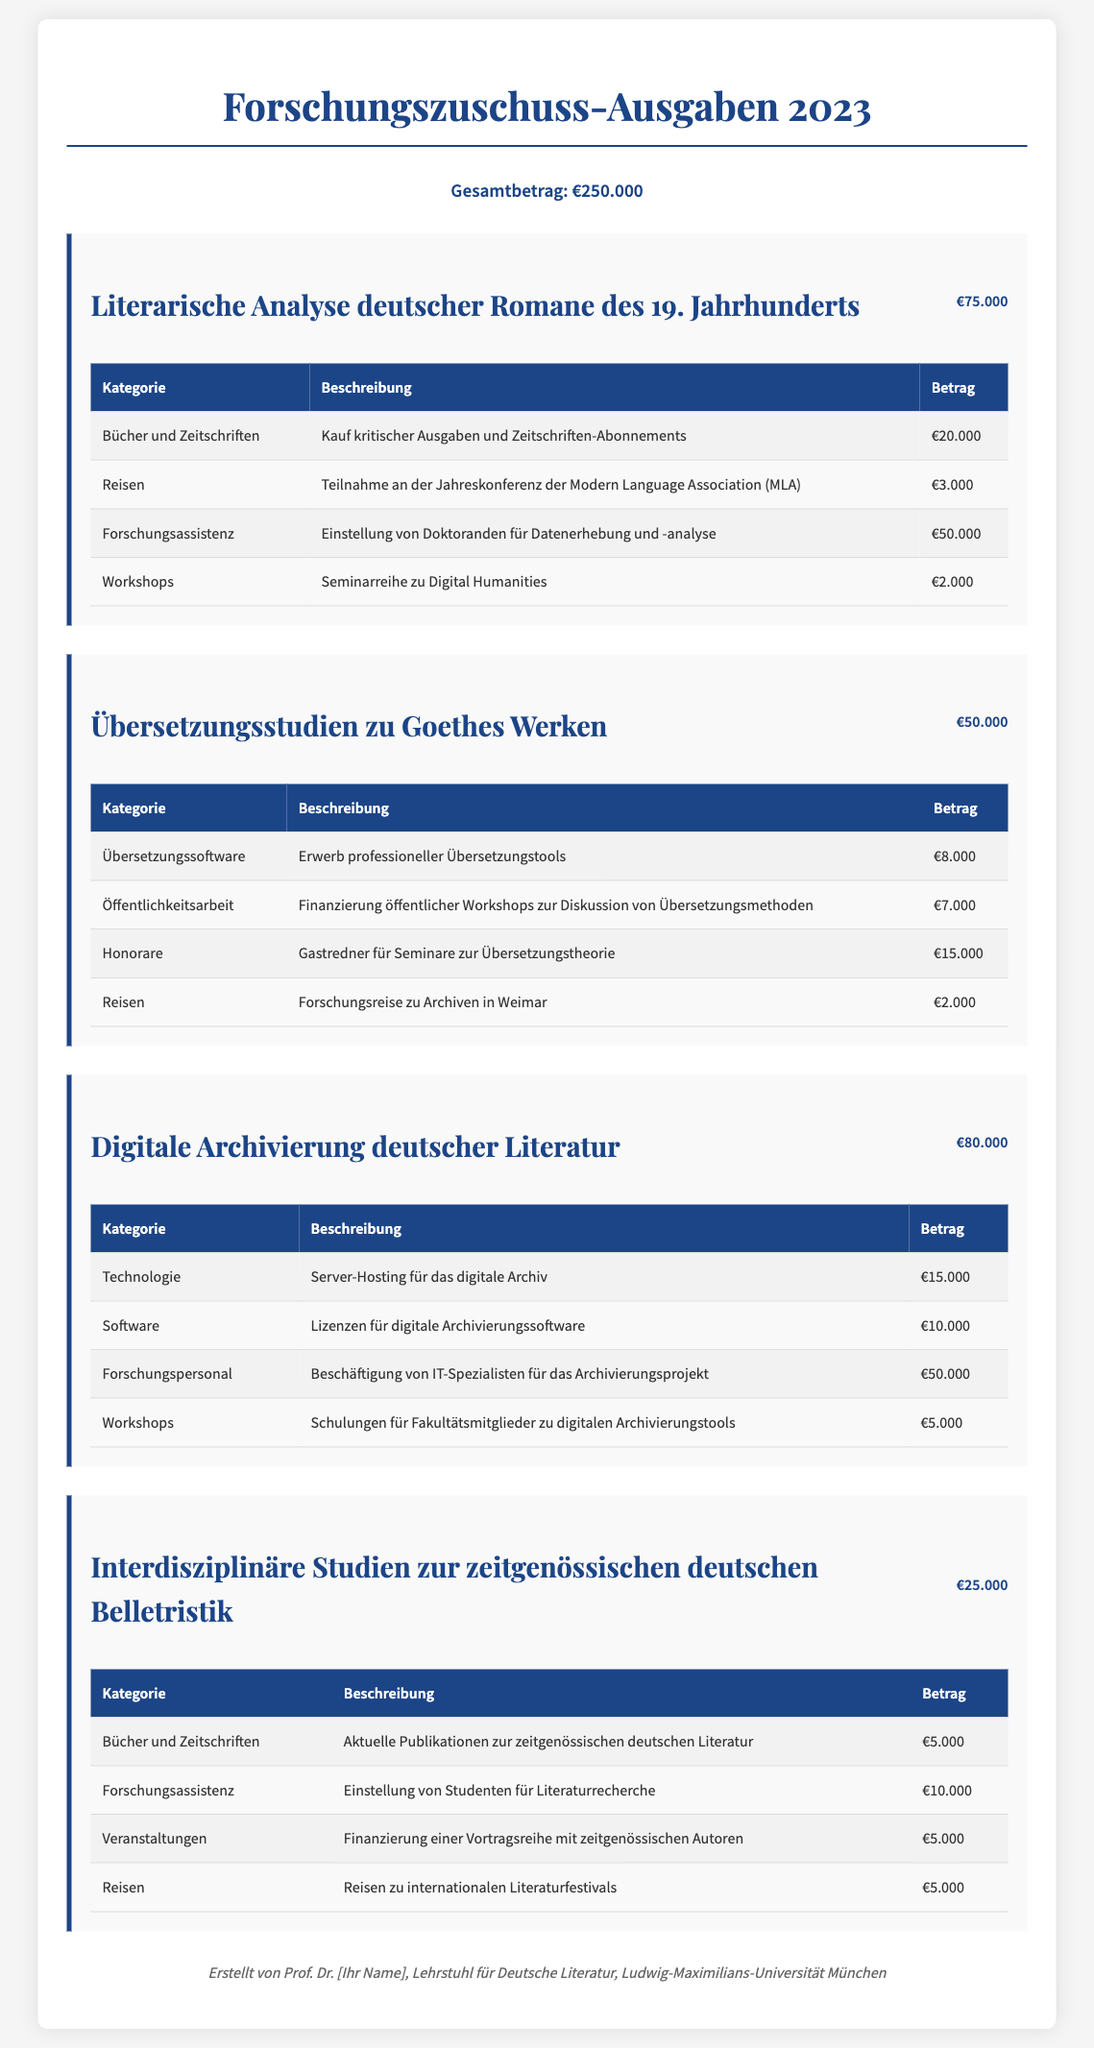What is the total amount of the research grant expenditures in 2023? The total amount is presented prominently in the document, which states the overall grant expenditures for the year.
Answer: €250.000 How much was spent on the project "Literarische Analyse deutscher Romane des 19. Jahrhunderts"? Each project has a specified amount listed right next to the project title, indicating the total expenditure for that project.
Answer: €75.000 What category received the highest funding within the project "Digitale Archivierung deutscher Literatur"? The document details various categories of expenditures with specified amounts, making it possible to determine which category was funded the most.
Answer: Forschungspersonal What was the amount spent on workshops in the project "Übersetzungsstudien zu Goethes Werken"? The table for each project lists expenditures along with their categories and descriptions; locating the category for workshops will reveal the exact amount.
Answer: €15.000 How many projects are detailed in the document? The document outlines expenditures for specific projects, each section representing one project, which allows for a count of the total projects discussed.
Answer: 4 What is the purpose of the funding for the project "Interdisziplinäre Studien zur zeitgenössischen deutschen Belletristik"? Each project section provides a title that describes its focus, which quickly hints at the purpose of the funding.
Answer: Zeitgenössische deutsche Belletristik Which project had the highest total expenditure? By comparing the total amounts listed for each project, one can discern which project incurred the most costs overall.
Answer: Digitale Archivierung deutscher Literatur 